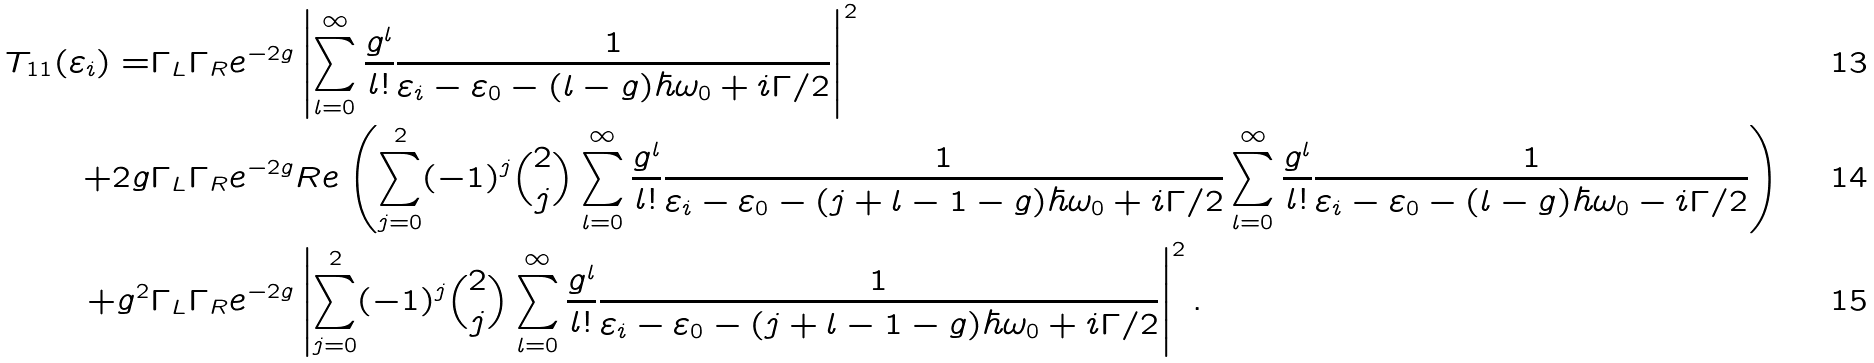<formula> <loc_0><loc_0><loc_500><loc_500>T _ { 1 1 } ( \varepsilon _ { i } ) = & \Gamma _ { L } \Gamma _ { R } e ^ { - 2 g } \left | \sum _ { l = 0 } ^ { \infty } \frac { g ^ { l } } { l ! } \frac { 1 } { \varepsilon _ { i } - \varepsilon _ { 0 } - ( l - g ) \hbar { \omega } _ { 0 } + i \Gamma / 2 } \right | ^ { 2 } \\ + 2 g & \Gamma _ { L } \Gamma _ { R } e ^ { - 2 g } R e \left ( \sum _ { j = 0 } ^ { 2 } ( - 1 ) ^ { j } \binom { 2 } { j } \sum _ { l = 0 } ^ { \infty } \frac { g ^ { l } } { l ! } \frac { 1 } { \varepsilon _ { i } - \varepsilon _ { 0 } - ( j + l - 1 - g ) \hbar { \omega } _ { 0 } + i \Gamma / 2 } \sum _ { l = 0 } ^ { \infty } \frac { g ^ { l } } { l ! } \frac { 1 } { \varepsilon _ { i } - \varepsilon _ { 0 } - ( l - g ) \hbar { \omega } _ { 0 } - i \Gamma / 2 } \right ) \\ + g ^ { 2 } & \Gamma _ { L } \Gamma _ { R } e ^ { - 2 g } \left | \sum _ { j = 0 } ^ { 2 } ( - 1 ) ^ { j } \binom { 2 } { j } \sum _ { l = 0 } ^ { \infty } \frac { g ^ { l } } { l ! } \frac { 1 } { \varepsilon _ { i } - \varepsilon _ { 0 } - ( j + l - 1 - g ) \hbar { \omega } _ { 0 } + i \Gamma / 2 } \right | ^ { 2 } .</formula> 